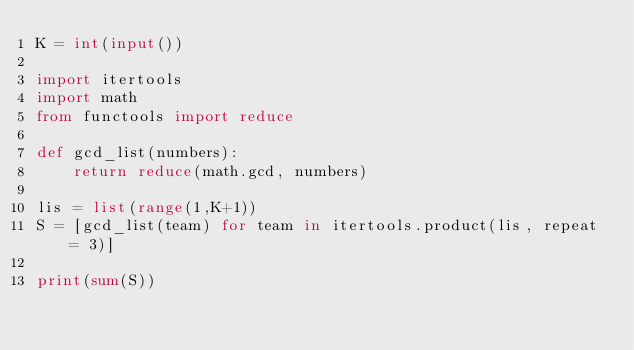<code> <loc_0><loc_0><loc_500><loc_500><_Python_>K = int(input())

import itertools
import math
from functools import reduce

def gcd_list(numbers):
    return reduce(math.gcd, numbers)

lis = list(range(1,K+1))
S = [gcd_list(team) for team in itertools.product(lis, repeat = 3)]

print(sum(S))
</code> 